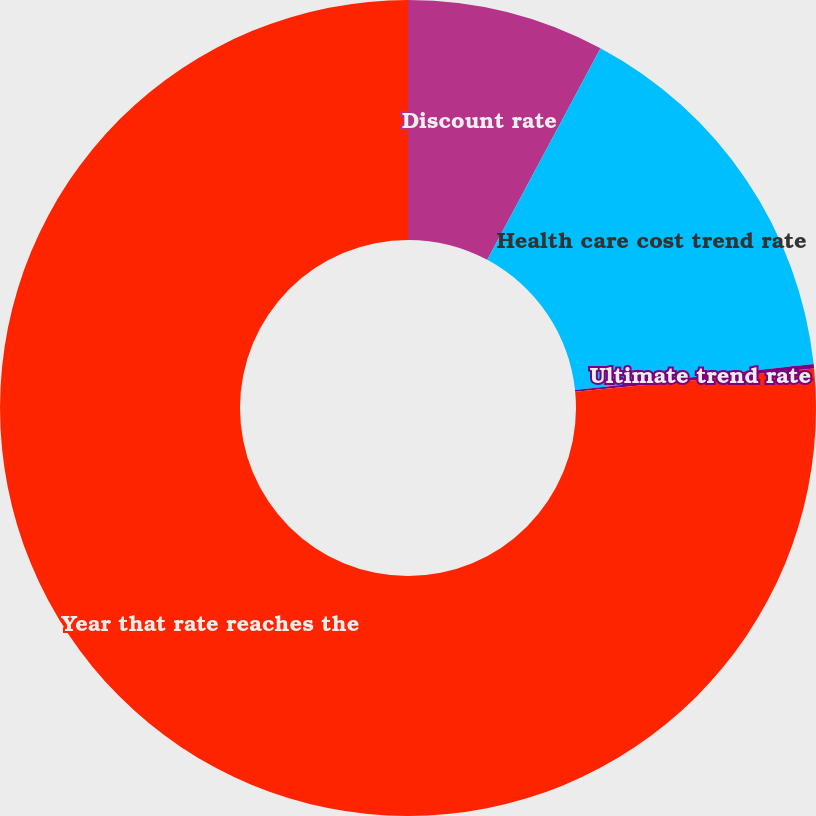Convert chart. <chart><loc_0><loc_0><loc_500><loc_500><pie_chart><fcel>Discount rate<fcel>Health care cost trend rate<fcel>Ultimate trend rate<fcel>Year that rate reaches the<nl><fcel>7.82%<fcel>15.46%<fcel>0.18%<fcel>76.54%<nl></chart> 